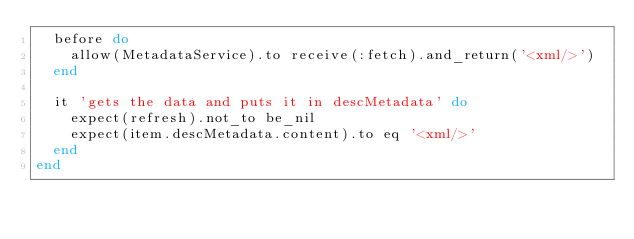Convert code to text. <code><loc_0><loc_0><loc_500><loc_500><_Ruby_>  before do
    allow(MetadataService).to receive(:fetch).and_return('<xml/>')
  end

  it 'gets the data and puts it in descMetadata' do
    expect(refresh).not_to be_nil
    expect(item.descMetadata.content).to eq '<xml/>'
  end
end
</code> 